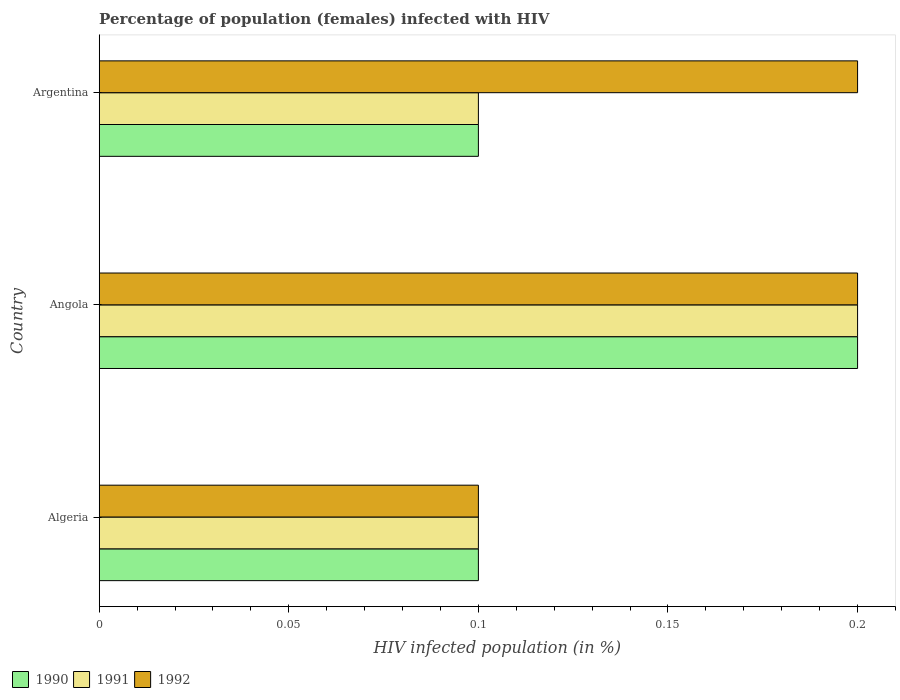How many different coloured bars are there?
Provide a succinct answer. 3. How many groups of bars are there?
Make the answer very short. 3. Are the number of bars per tick equal to the number of legend labels?
Your answer should be very brief. Yes. How many bars are there on the 2nd tick from the top?
Make the answer very short. 3. What is the label of the 3rd group of bars from the top?
Offer a very short reply. Algeria. In how many cases, is the number of bars for a given country not equal to the number of legend labels?
Ensure brevity in your answer.  0. What is the percentage of HIV infected female population in 1992 in Argentina?
Provide a short and direct response. 0.2. Across all countries, what is the minimum percentage of HIV infected female population in 1990?
Keep it short and to the point. 0.1. In which country was the percentage of HIV infected female population in 1991 maximum?
Offer a terse response. Angola. In which country was the percentage of HIV infected female population in 1991 minimum?
Ensure brevity in your answer.  Algeria. What is the total percentage of HIV infected female population in 1991 in the graph?
Your answer should be compact. 0.4. What is the difference between the percentage of HIV infected female population in 1991 in Algeria and that in Angola?
Ensure brevity in your answer.  -0.1. What is the average percentage of HIV infected female population in 1990 per country?
Offer a very short reply. 0.13. In how many countries, is the percentage of HIV infected female population in 1992 greater than 0.18000000000000002 %?
Provide a succinct answer. 2. What is the difference between the highest and the second highest percentage of HIV infected female population in 1991?
Give a very brief answer. 0.1. Is it the case that in every country, the sum of the percentage of HIV infected female population in 1991 and percentage of HIV infected female population in 1992 is greater than the percentage of HIV infected female population in 1990?
Your answer should be compact. Yes. What is the difference between two consecutive major ticks on the X-axis?
Offer a terse response. 0.05. Does the graph contain any zero values?
Provide a short and direct response. No. Does the graph contain grids?
Your response must be concise. No. How many legend labels are there?
Make the answer very short. 3. How are the legend labels stacked?
Give a very brief answer. Horizontal. What is the title of the graph?
Your answer should be compact. Percentage of population (females) infected with HIV. What is the label or title of the X-axis?
Keep it short and to the point. HIV infected population (in %). What is the label or title of the Y-axis?
Offer a terse response. Country. What is the HIV infected population (in %) in 1992 in Algeria?
Ensure brevity in your answer.  0.1. What is the HIV infected population (in %) of 1990 in Angola?
Provide a short and direct response. 0.2. What is the HIV infected population (in %) of 1991 in Angola?
Make the answer very short. 0.2. What is the HIV infected population (in %) of 1991 in Argentina?
Provide a succinct answer. 0.1. What is the HIV infected population (in %) of 1992 in Argentina?
Provide a short and direct response. 0.2. Across all countries, what is the maximum HIV infected population (in %) of 1991?
Provide a succinct answer. 0.2. Across all countries, what is the minimum HIV infected population (in %) in 1990?
Keep it short and to the point. 0.1. Across all countries, what is the minimum HIV infected population (in %) of 1991?
Your answer should be very brief. 0.1. Across all countries, what is the minimum HIV infected population (in %) of 1992?
Ensure brevity in your answer.  0.1. What is the total HIV infected population (in %) of 1990 in the graph?
Make the answer very short. 0.4. What is the total HIV infected population (in %) of 1992 in the graph?
Your answer should be compact. 0.5. What is the difference between the HIV infected population (in %) of 1991 in Algeria and that in Angola?
Your answer should be compact. -0.1. What is the difference between the HIV infected population (in %) in 1992 in Algeria and that in Angola?
Your response must be concise. -0.1. What is the difference between the HIV infected population (in %) of 1990 in Algeria and that in Argentina?
Provide a short and direct response. 0. What is the difference between the HIV infected population (in %) of 1992 in Algeria and that in Argentina?
Make the answer very short. -0.1. What is the difference between the HIV infected population (in %) of 1991 in Angola and that in Argentina?
Provide a short and direct response. 0.1. What is the difference between the HIV infected population (in %) in 1990 in Algeria and the HIV infected population (in %) in 1991 in Argentina?
Ensure brevity in your answer.  0. What is the difference between the HIV infected population (in %) in 1990 in Algeria and the HIV infected population (in %) in 1992 in Argentina?
Give a very brief answer. -0.1. What is the difference between the HIV infected population (in %) of 1990 in Angola and the HIV infected population (in %) of 1992 in Argentina?
Your response must be concise. 0. What is the difference between the HIV infected population (in %) of 1991 in Angola and the HIV infected population (in %) of 1992 in Argentina?
Your answer should be compact. 0. What is the average HIV infected population (in %) of 1990 per country?
Provide a succinct answer. 0.13. What is the average HIV infected population (in %) of 1991 per country?
Give a very brief answer. 0.13. What is the average HIV infected population (in %) of 1992 per country?
Offer a terse response. 0.17. What is the difference between the HIV infected population (in %) of 1990 and HIV infected population (in %) of 1992 in Algeria?
Make the answer very short. 0. What is the difference between the HIV infected population (in %) of 1990 and HIV infected population (in %) of 1991 in Angola?
Make the answer very short. 0. What is the difference between the HIV infected population (in %) of 1990 and HIV infected population (in %) of 1992 in Angola?
Offer a terse response. 0. What is the difference between the HIV infected population (in %) of 1990 and HIV infected population (in %) of 1992 in Argentina?
Provide a short and direct response. -0.1. What is the difference between the HIV infected population (in %) of 1991 and HIV infected population (in %) of 1992 in Argentina?
Provide a succinct answer. -0.1. What is the ratio of the HIV infected population (in %) in 1991 in Algeria to that in Angola?
Provide a succinct answer. 0.5. What is the ratio of the HIV infected population (in %) in 1990 in Angola to that in Argentina?
Your response must be concise. 2. What is the ratio of the HIV infected population (in %) of 1991 in Angola to that in Argentina?
Make the answer very short. 2. What is the ratio of the HIV infected population (in %) of 1992 in Angola to that in Argentina?
Keep it short and to the point. 1. What is the difference between the highest and the second highest HIV infected population (in %) of 1991?
Your answer should be compact. 0.1. What is the difference between the highest and the second highest HIV infected population (in %) of 1992?
Offer a very short reply. 0. 